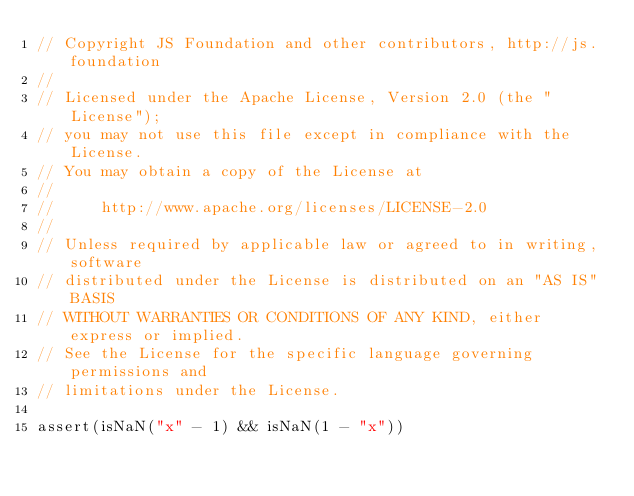<code> <loc_0><loc_0><loc_500><loc_500><_JavaScript_>// Copyright JS Foundation and other contributors, http://js.foundation
//
// Licensed under the Apache License, Version 2.0 (the "License");
// you may not use this file except in compliance with the License.
// You may obtain a copy of the License at
//
//     http://www.apache.org/licenses/LICENSE-2.0
//
// Unless required by applicable law or agreed to in writing, software
// distributed under the License is distributed on an "AS IS" BASIS
// WITHOUT WARRANTIES OR CONDITIONS OF ANY KIND, either express or implied.
// See the License for the specific language governing permissions and
// limitations under the License.

assert(isNaN("x" - 1) && isNaN(1 - "x"))</code> 